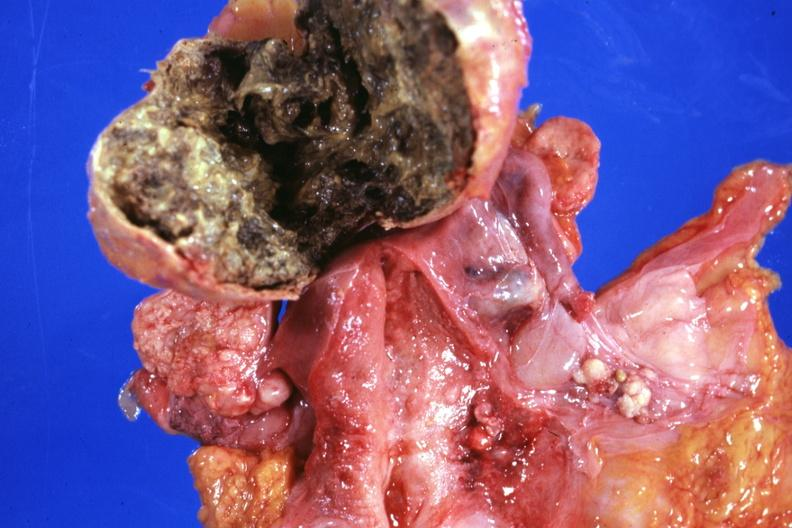s carcinoma metastatic lung present?
Answer the question using a single word or phrase. No 